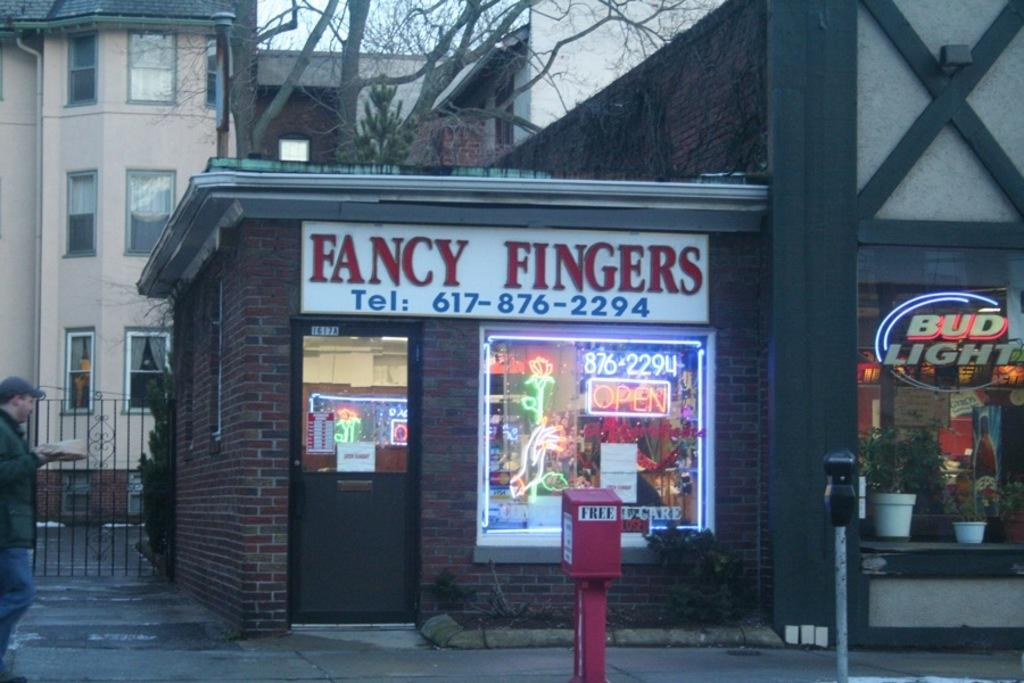<image>
Write a terse but informative summary of the picture. A shop with the words fancy fingers at the top 